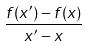<formula> <loc_0><loc_0><loc_500><loc_500>\frac { f ( x ^ { \prime } ) - f ( x ) } { x ^ { \prime } - x }</formula> 